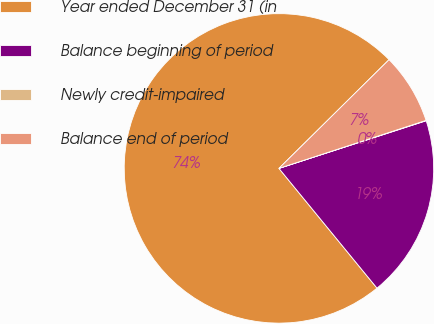<chart> <loc_0><loc_0><loc_500><loc_500><pie_chart><fcel>Year ended December 31 (in<fcel>Balance beginning of period<fcel>Newly credit-impaired<fcel>Balance end of period<nl><fcel>73.52%<fcel>19.06%<fcel>0.04%<fcel>7.38%<nl></chart> 